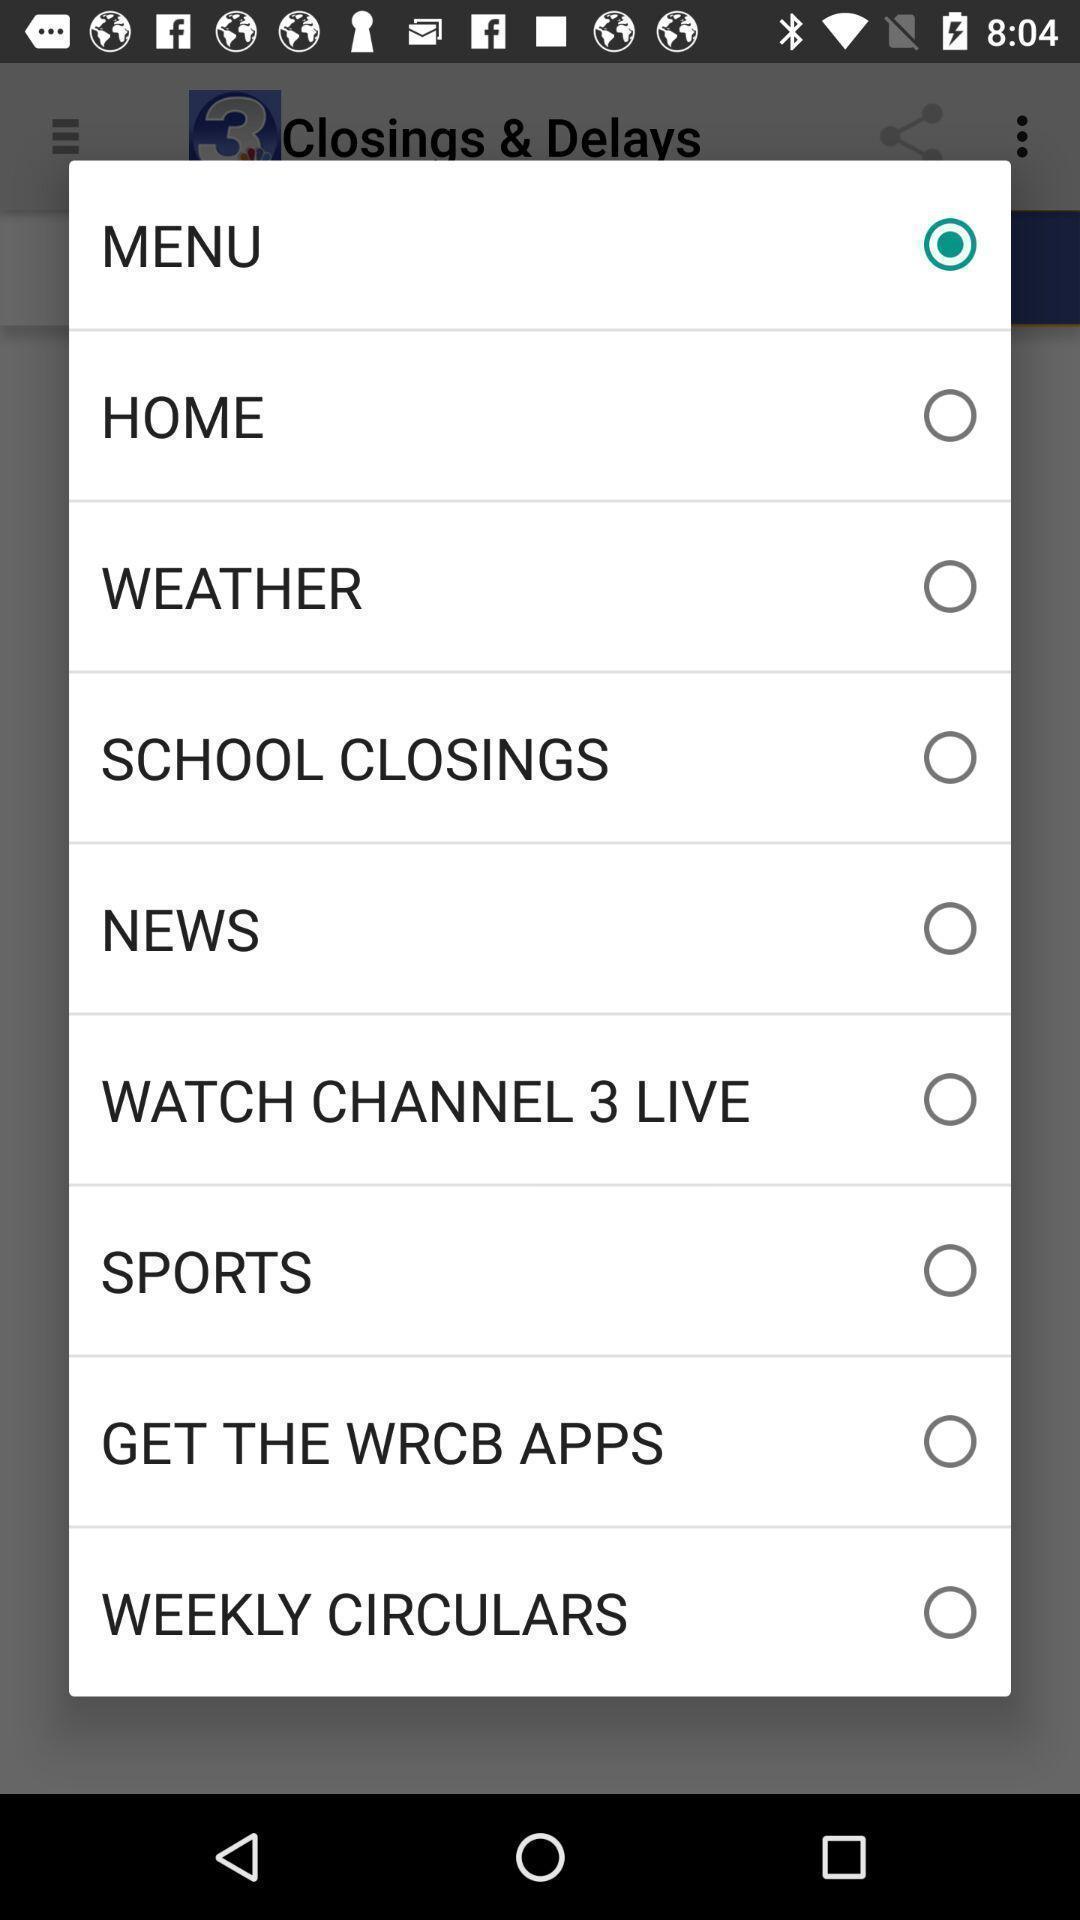Describe this image in words. Pop-up showing different options. 